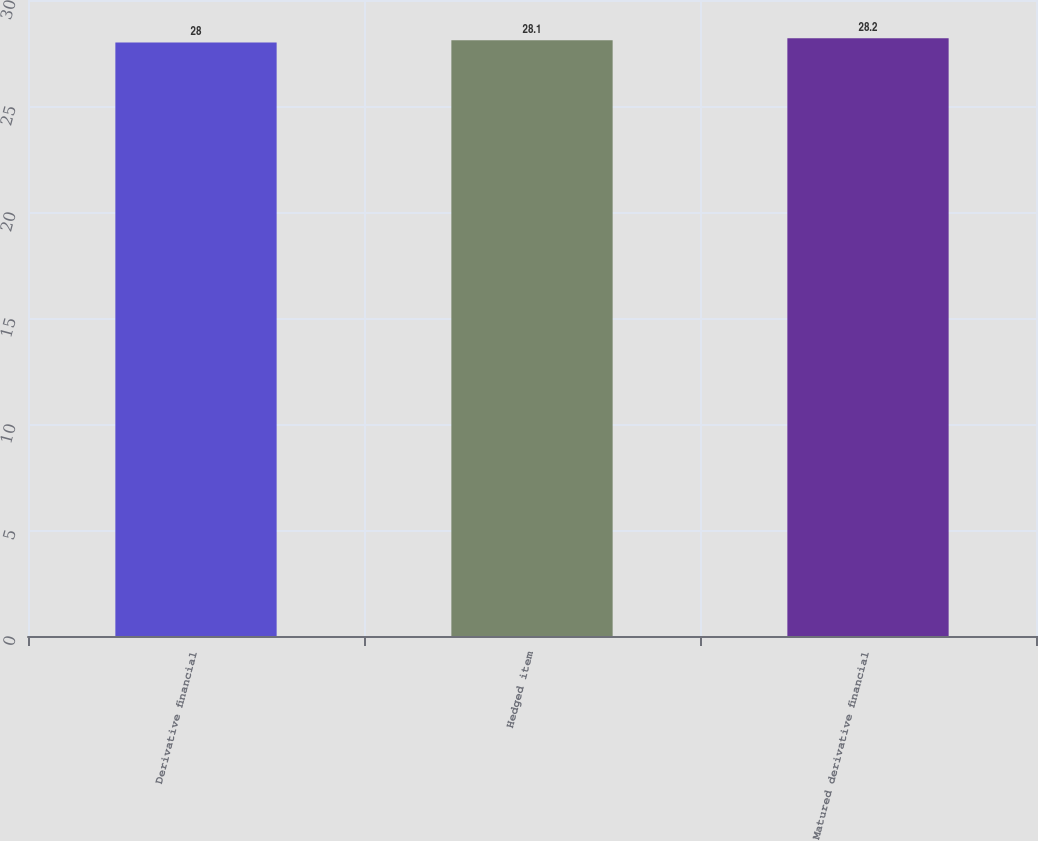Convert chart to OTSL. <chart><loc_0><loc_0><loc_500><loc_500><bar_chart><fcel>Derivative financial<fcel>Hedged item<fcel>Matured derivative financial<nl><fcel>28<fcel>28.1<fcel>28.2<nl></chart> 